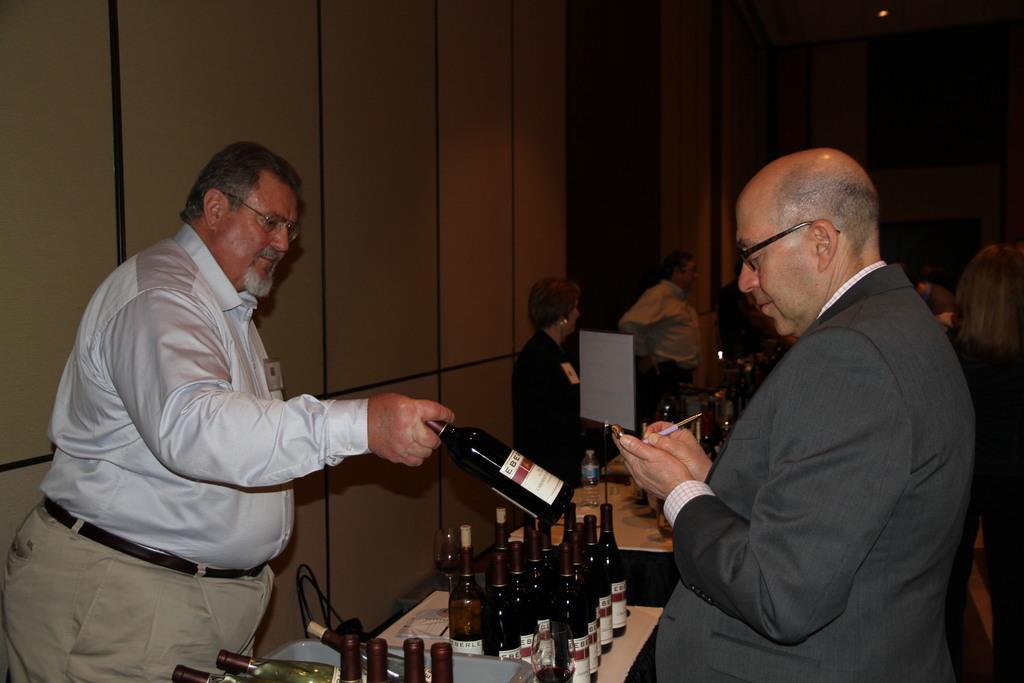In one or two sentences, can you explain what this image depicts? In this image on the right there is a man he wear suit and shirt he is writing something. On the left there is a man he wear shirt, belt and trouser he is holding a table. In the middle there is a table on that there are many bottles. In the background there are some people and wall. 